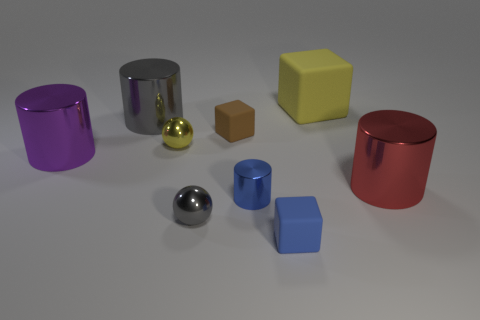Add 1 gray shiny cylinders. How many objects exist? 10 Subtract all cylinders. How many objects are left? 5 Add 3 purple things. How many purple things are left? 4 Add 9 tiny blue matte cubes. How many tiny blue matte cubes exist? 10 Subtract 0 green cylinders. How many objects are left? 9 Subtract all big brown rubber blocks. Subtract all big yellow matte objects. How many objects are left? 8 